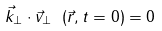<formula> <loc_0><loc_0><loc_500><loc_500>\vec { k } _ { \perp } \cdot \vec { v } _ { \perp } \ ( \vec { r } , t = 0 ) = 0</formula> 